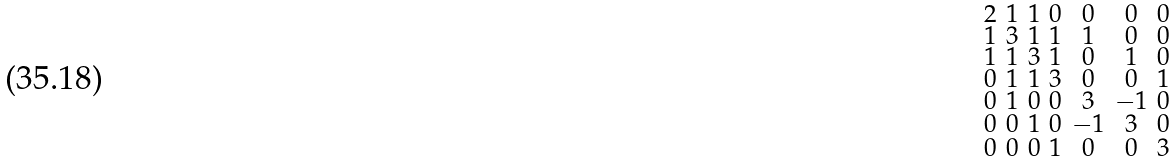Convert formula to latex. <formula><loc_0><loc_0><loc_500><loc_500>\begin{smallmatrix} 2 & 1 & 1 & 0 & 0 & 0 & 0 \\ 1 & 3 & 1 & 1 & 1 & 0 & 0 \\ 1 & 1 & 3 & 1 & 0 & 1 & 0 \\ 0 & 1 & 1 & 3 & 0 & 0 & 1 \\ 0 & 1 & 0 & 0 & 3 & - 1 & 0 \\ 0 & 0 & 1 & 0 & - 1 & 3 & 0 \\ 0 & 0 & 0 & 1 & 0 & 0 & 3 \end{smallmatrix}</formula> 